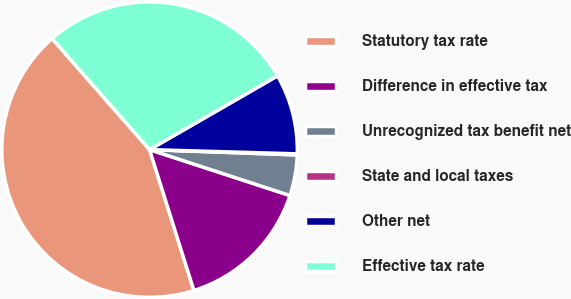Convert chart to OTSL. <chart><loc_0><loc_0><loc_500><loc_500><pie_chart><fcel>Statutory tax rate<fcel>Difference in effective tax<fcel>Unrecognized tax benefit net<fcel>State and local taxes<fcel>Other net<fcel>Effective tax rate<nl><fcel>43.39%<fcel>15.12%<fcel>4.45%<fcel>0.12%<fcel>8.78%<fcel>28.14%<nl></chart> 